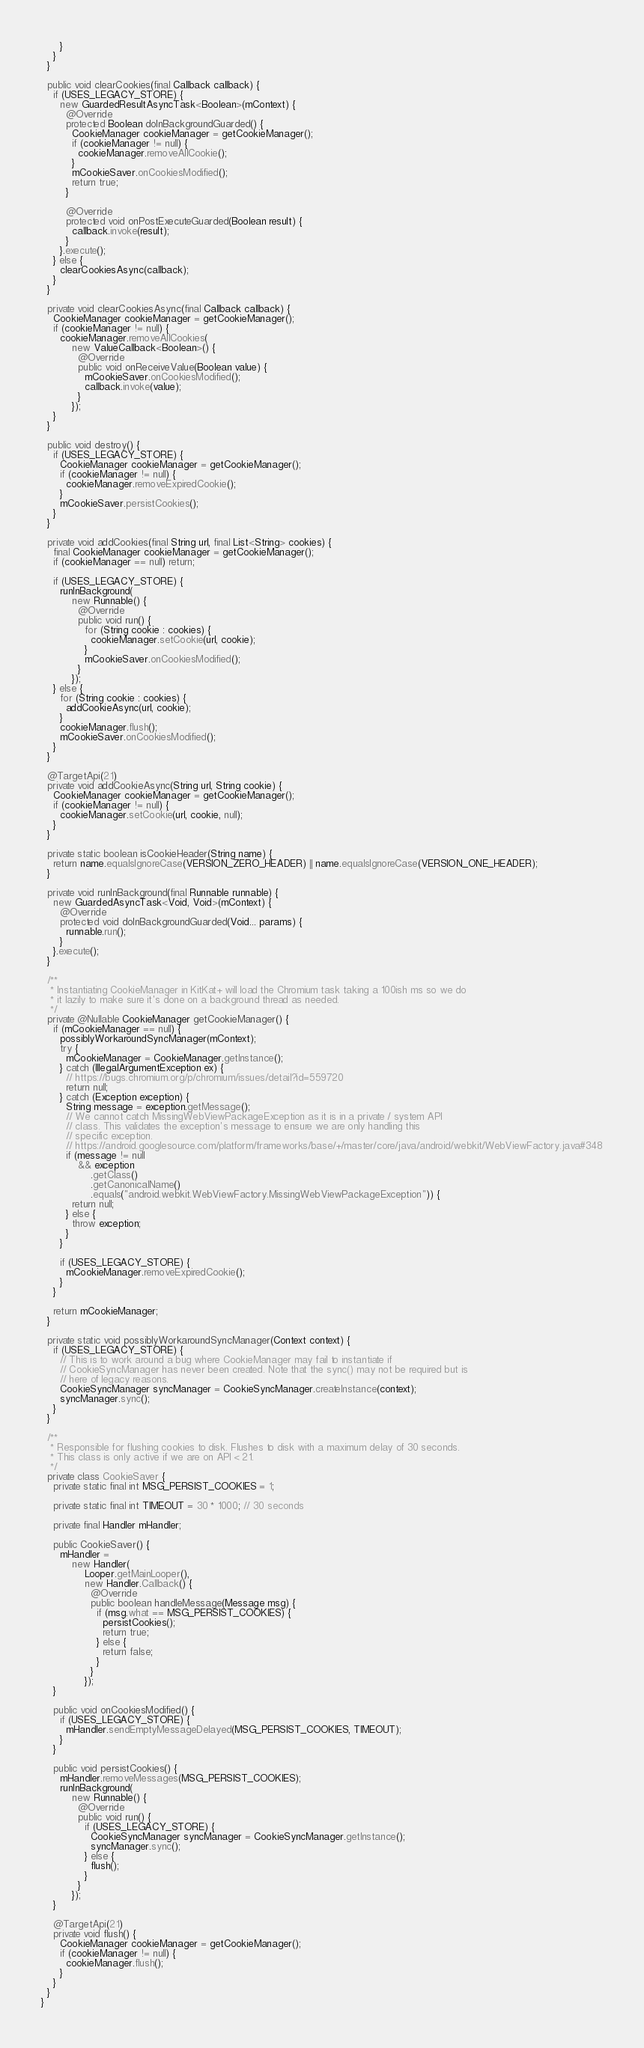<code> <loc_0><loc_0><loc_500><loc_500><_Java_>      }
    }
  }

  public void clearCookies(final Callback callback) {
    if (USES_LEGACY_STORE) {
      new GuardedResultAsyncTask<Boolean>(mContext) {
        @Override
        protected Boolean doInBackgroundGuarded() {
          CookieManager cookieManager = getCookieManager();
          if (cookieManager != null) {
            cookieManager.removeAllCookie();
          }
          mCookieSaver.onCookiesModified();
          return true;
        }

        @Override
        protected void onPostExecuteGuarded(Boolean result) {
          callback.invoke(result);
        }
      }.execute();
    } else {
      clearCookiesAsync(callback);
    }
  }

  private void clearCookiesAsync(final Callback callback) {
    CookieManager cookieManager = getCookieManager();
    if (cookieManager != null) {
      cookieManager.removeAllCookies(
          new ValueCallback<Boolean>() {
            @Override
            public void onReceiveValue(Boolean value) {
              mCookieSaver.onCookiesModified();
              callback.invoke(value);
            }
          });
    }
  }

  public void destroy() {
    if (USES_LEGACY_STORE) {
      CookieManager cookieManager = getCookieManager();
      if (cookieManager != null) {
        cookieManager.removeExpiredCookie();
      }
      mCookieSaver.persistCookies();
    }
  }

  private void addCookies(final String url, final List<String> cookies) {
    final CookieManager cookieManager = getCookieManager();
    if (cookieManager == null) return;

    if (USES_LEGACY_STORE) {
      runInBackground(
          new Runnable() {
            @Override
            public void run() {
              for (String cookie : cookies) {
                cookieManager.setCookie(url, cookie);
              }
              mCookieSaver.onCookiesModified();
            }
          });
    } else {
      for (String cookie : cookies) {
        addCookieAsync(url, cookie);
      }
      cookieManager.flush();
      mCookieSaver.onCookiesModified();
    }
  }

  @TargetApi(21)
  private void addCookieAsync(String url, String cookie) {
    CookieManager cookieManager = getCookieManager();
    if (cookieManager != null) {
      cookieManager.setCookie(url, cookie, null);
    }
  }

  private static boolean isCookieHeader(String name) {
    return name.equalsIgnoreCase(VERSION_ZERO_HEADER) || name.equalsIgnoreCase(VERSION_ONE_HEADER);
  }

  private void runInBackground(final Runnable runnable) {
    new GuardedAsyncTask<Void, Void>(mContext) {
      @Override
      protected void doInBackgroundGuarded(Void... params) {
        runnable.run();
      }
    }.execute();
  }

  /**
   * Instantiating CookieManager in KitKat+ will load the Chromium task taking a 100ish ms so we do
   * it lazily to make sure it's done on a background thread as needed.
   */
  private @Nullable CookieManager getCookieManager() {
    if (mCookieManager == null) {
      possiblyWorkaroundSyncManager(mContext);
      try {
        mCookieManager = CookieManager.getInstance();
      } catch (IllegalArgumentException ex) {
        // https://bugs.chromium.org/p/chromium/issues/detail?id=559720
        return null;
      } catch (Exception exception) {
        String message = exception.getMessage();
        // We cannot catch MissingWebViewPackageException as it is in a private / system API
        // class. This validates the exception's message to ensure we are only handling this
        // specific exception.
        // https://android.googlesource.com/platform/frameworks/base/+/master/core/java/android/webkit/WebViewFactory.java#348
        if (message != null
            && exception
                .getClass()
                .getCanonicalName()
                .equals("android.webkit.WebViewFactory.MissingWebViewPackageException")) {
          return null;
        } else {
          throw exception;
        }
      }

      if (USES_LEGACY_STORE) {
        mCookieManager.removeExpiredCookie();
      }
    }

    return mCookieManager;
  }

  private static void possiblyWorkaroundSyncManager(Context context) {
    if (USES_LEGACY_STORE) {
      // This is to work around a bug where CookieManager may fail to instantiate if
      // CookieSyncManager has never been created. Note that the sync() may not be required but is
      // here of legacy reasons.
      CookieSyncManager syncManager = CookieSyncManager.createInstance(context);
      syncManager.sync();
    }
  }

  /**
   * Responsible for flushing cookies to disk. Flushes to disk with a maximum delay of 30 seconds.
   * This class is only active if we are on API < 21.
   */
  private class CookieSaver {
    private static final int MSG_PERSIST_COOKIES = 1;

    private static final int TIMEOUT = 30 * 1000; // 30 seconds

    private final Handler mHandler;

    public CookieSaver() {
      mHandler =
          new Handler(
              Looper.getMainLooper(),
              new Handler.Callback() {
                @Override
                public boolean handleMessage(Message msg) {
                  if (msg.what == MSG_PERSIST_COOKIES) {
                    persistCookies();
                    return true;
                  } else {
                    return false;
                  }
                }
              });
    }

    public void onCookiesModified() {
      if (USES_LEGACY_STORE) {
        mHandler.sendEmptyMessageDelayed(MSG_PERSIST_COOKIES, TIMEOUT);
      }
    }

    public void persistCookies() {
      mHandler.removeMessages(MSG_PERSIST_COOKIES);
      runInBackground(
          new Runnable() {
            @Override
            public void run() {
              if (USES_LEGACY_STORE) {
                CookieSyncManager syncManager = CookieSyncManager.getInstance();
                syncManager.sync();
              } else {
                flush();
              }
            }
          });
    }

    @TargetApi(21)
    private void flush() {
      CookieManager cookieManager = getCookieManager();
      if (cookieManager != null) {
        cookieManager.flush();
      }
    }
  }
}
</code> 